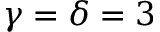<formula> <loc_0><loc_0><loc_500><loc_500>\gamma = \delta = 3</formula> 